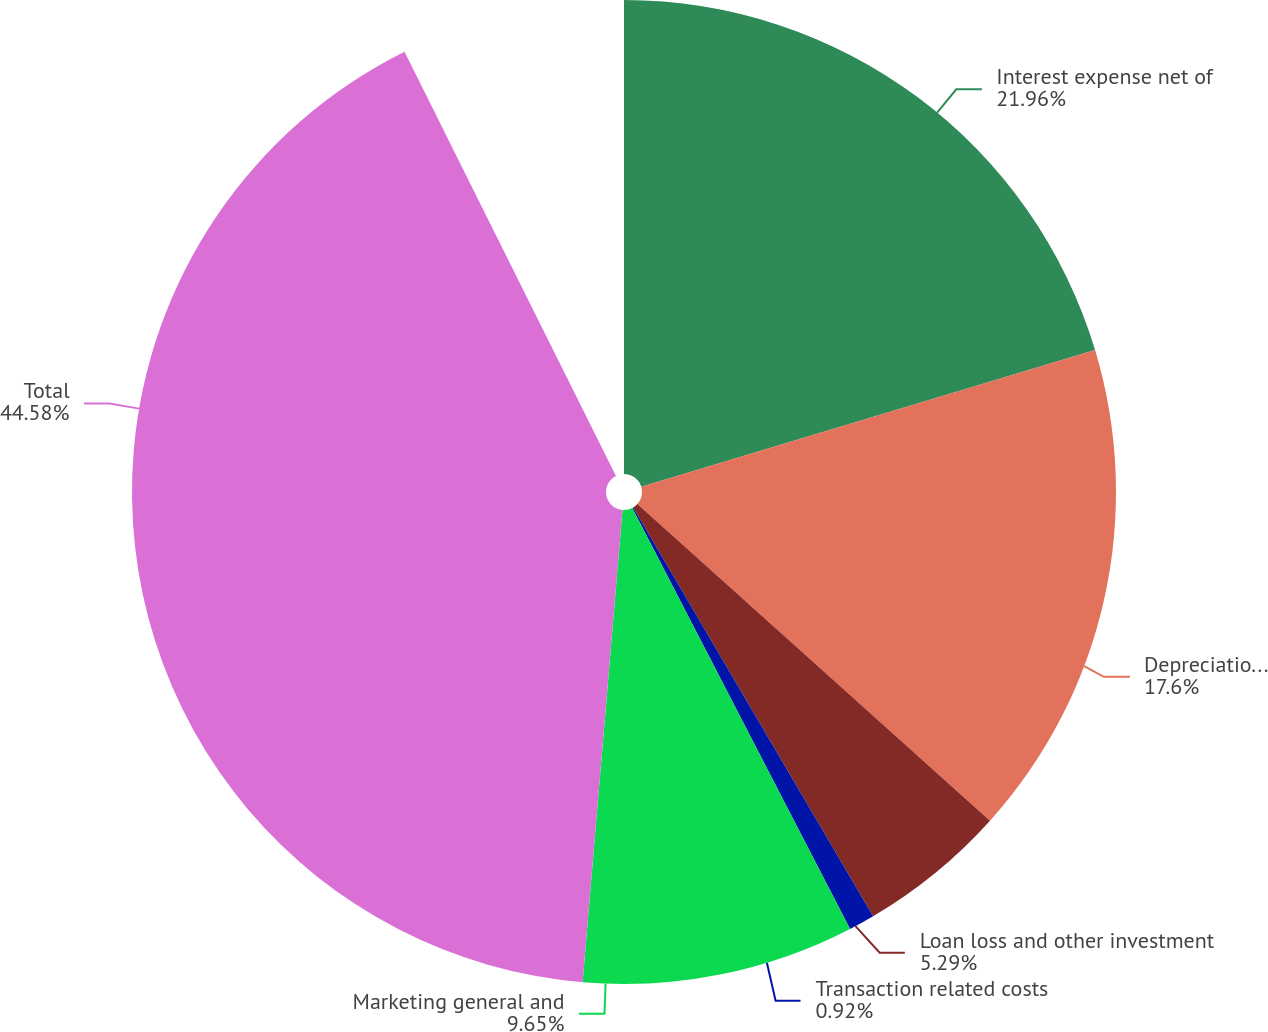Convert chart. <chart><loc_0><loc_0><loc_500><loc_500><pie_chart><fcel>Interest expense net of<fcel>Depreciation and amortization<fcel>Loan loss and other investment<fcel>Transaction related costs<fcel>Marketing general and<fcel>Total<nl><fcel>21.96%<fcel>17.6%<fcel>5.29%<fcel>0.92%<fcel>9.65%<fcel>44.58%<nl></chart> 